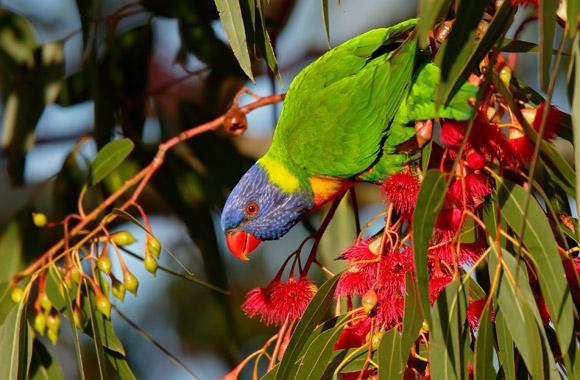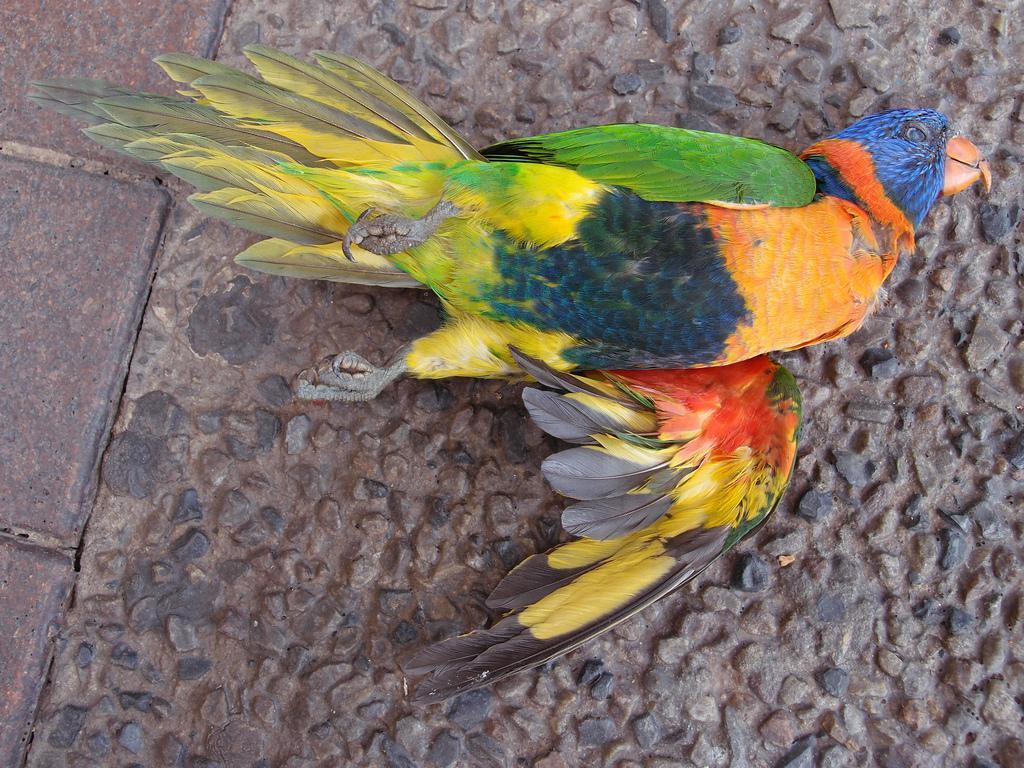The first image is the image on the left, the second image is the image on the right. For the images displayed, is the sentence "There are at least two birds in the image on the left." factually correct? Answer yes or no. No. The first image is the image on the left, the second image is the image on the right. For the images shown, is this caption "At least eight colorful birds are gathered together, each having a blue head." true? Answer yes or no. No. 